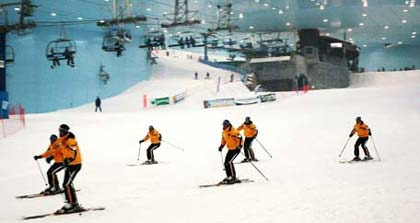What objects are primarily visible in the photo? In the photo, the primary objects you can see are several skiers equipped with ski poles, making their way down a snowy slope. There's also a ski lift in the background with multiple chairs suspended on a cable, and some structures are visible in the distance, possibly for operational purposes. 